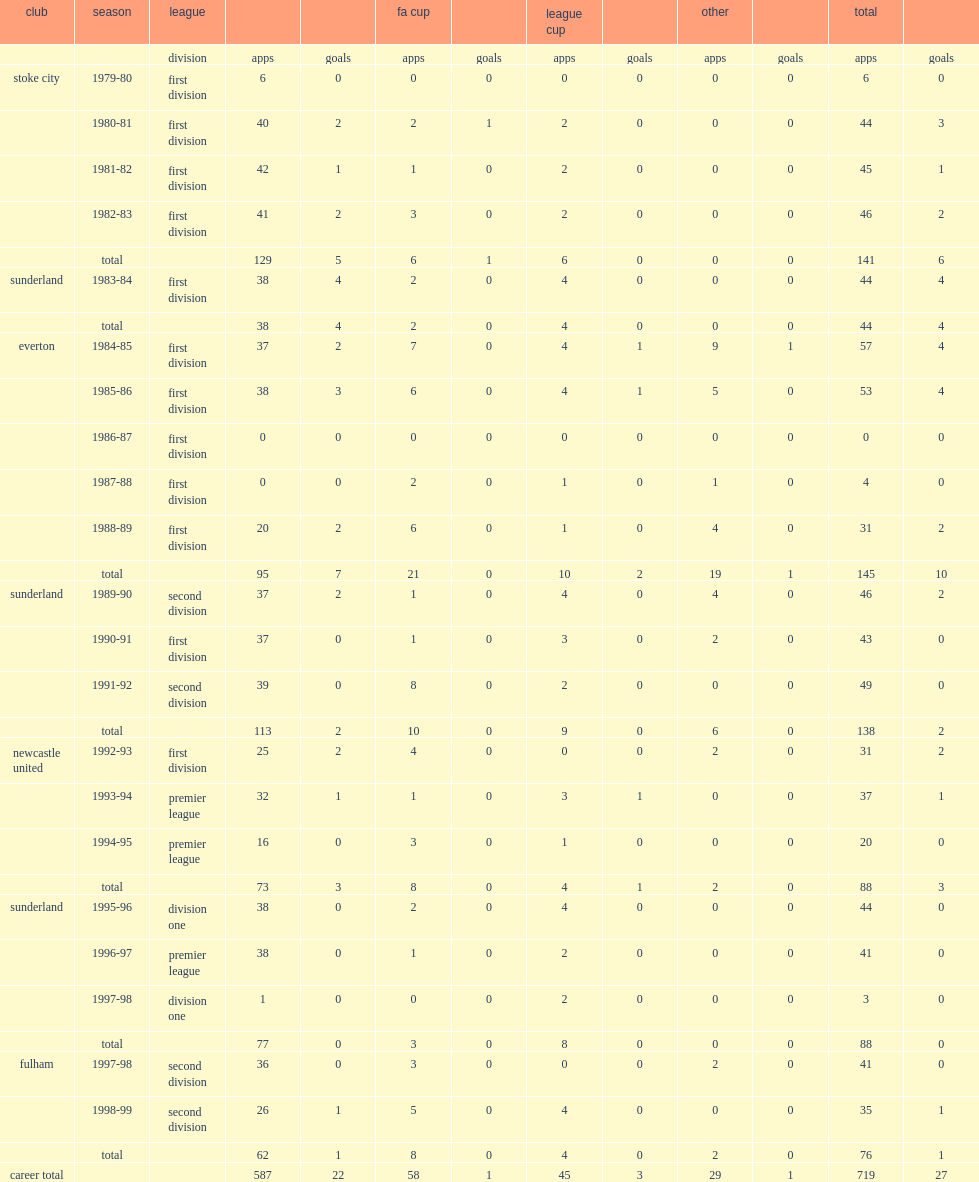How many appearances did paul bracewell from stoke make? 141.0. How many goals did paul bracewell from stoke make? 6.0. 